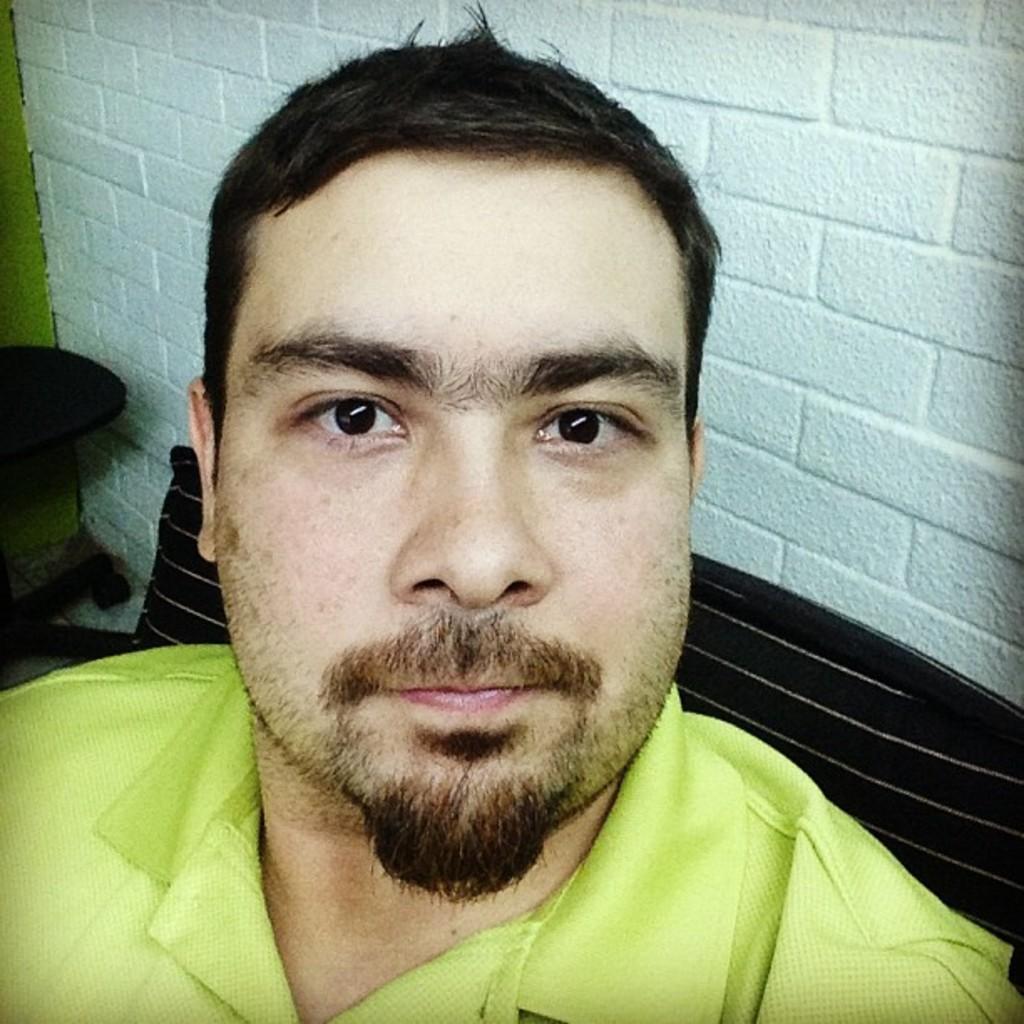Can you describe this image briefly? In the picture we can see a man standing and wearing a green T-shirt and in the background, we can see a bench which is brown in color and a wall which is white in color. 